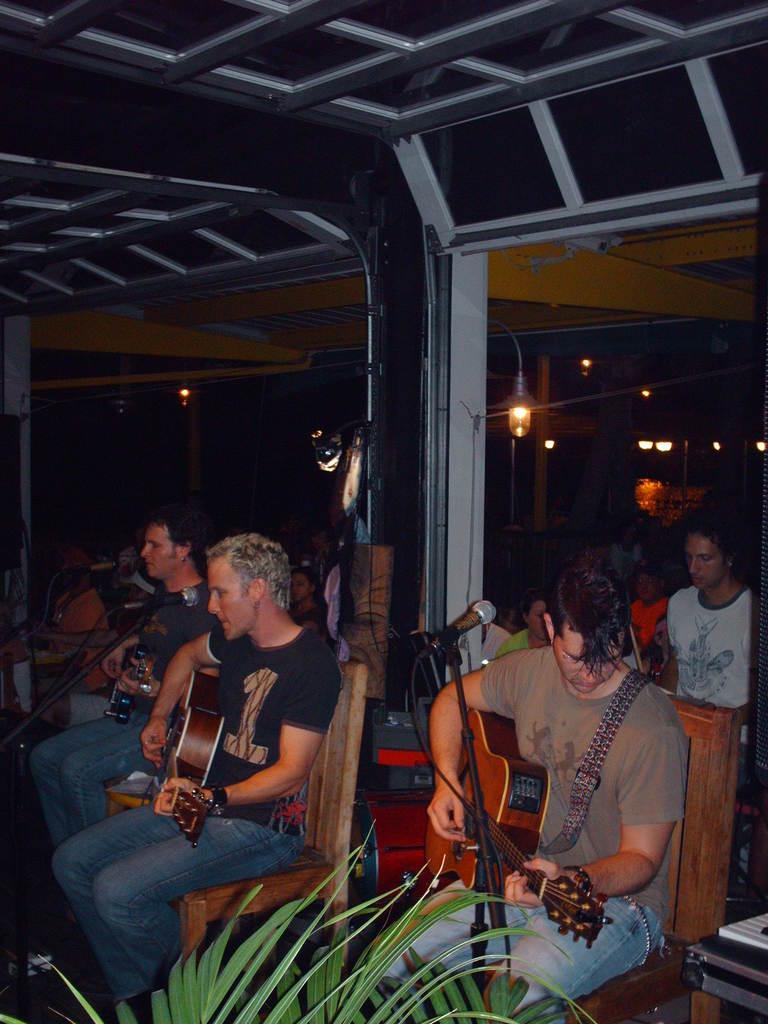How would you summarize this image in a sentence or two? In this image I can see a group of people are sitting on a chair and playing a guitar in front of a microphone 